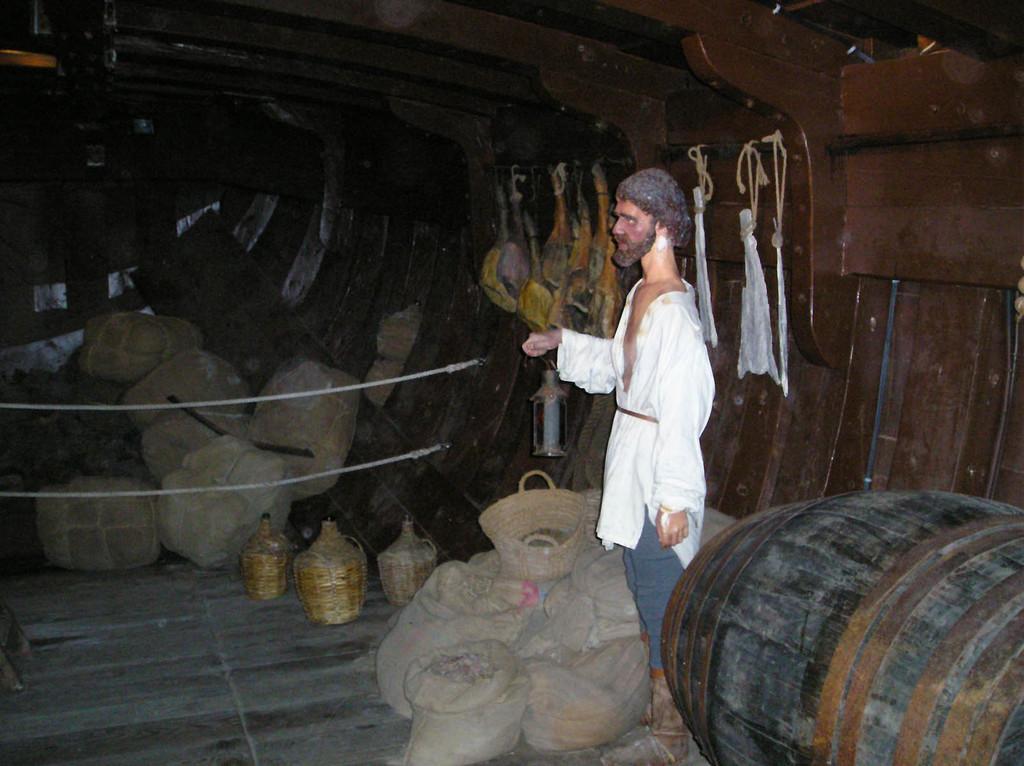How would you summarize this image in a sentence or two? In this image I see a depiction of a man who is holding a thing in his hand and I see few things changed over here and I see the wooden thing over here and I see the floor on which there are many things. 